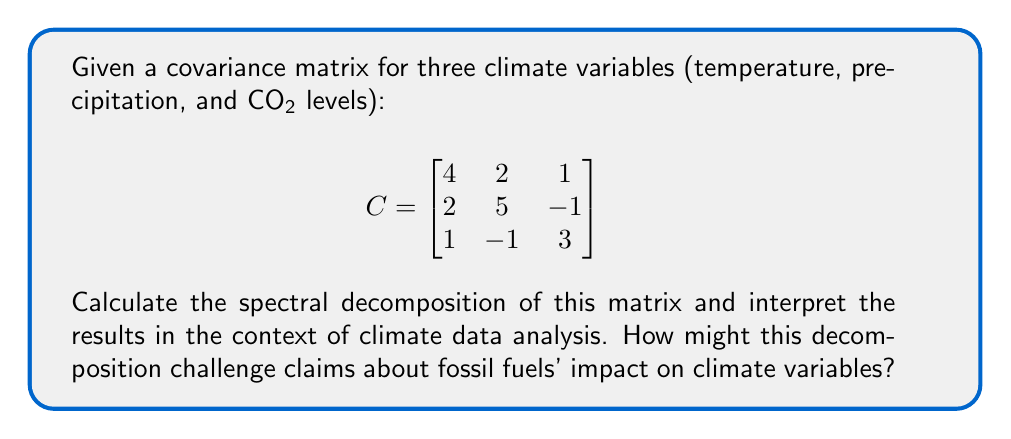Can you solve this math problem? 1) To find the spectral decomposition, we need to calculate the eigenvalues and eigenvectors of the covariance matrix C.

2) Find the eigenvalues by solving the characteristic equation:
   $$det(C - \lambda I) = 0$$
   $$(4-\lambda)(5-\lambda)(3-\lambda) - (4-\lambda)(-1)^2 - 1(5-\lambda) - 4(2)^2 + 2(2)(1) + 1(-1)(2) = 0$$
   $$-\lambda^3 + 12\lambda^2 - 41\lambda + 38 = 0$$

3) Solving this equation gives us the eigenvalues:
   $$\lambda_1 \approx 7.27, \lambda_2 \approx 3.54, \lambda_3 \approx 1.19$$

4) For each eigenvalue, find the corresponding eigenvector by solving:
   $$(C - \lambda_i I)v_i = 0$$

5) After normalization, the eigenvectors are approximately:
   $$v_1 \approx [0.52, 0.78, 0.35]^T$$
   $$v_2 \approx [-0.70, 0.09, 0.71]^T$$
   $$v_3 \approx [0.49, -0.62, 0.61]^T$$

6) The spectral decomposition is:
   $$C = V\Lambda V^T$$
   where $V$ is the matrix of eigenvectors and $\Lambda$ is the diagonal matrix of eigenvalues.

7) Interpretation: The first principal component (corresponding to $\lambda_1$) explains about 60.6% of the total variance, showing a strong positive correlation between all variables. The second component (29.5% of variance) contrasts CO2 levels with temperature. The third component (9.9% of variance) shows a complex relationship between all three variables.

8) This decomposition challenges simplistic claims about fossil fuels' impact by revealing complex interrelationships between climate variables. It suggests that while there is a dominant trend (PC1) where all variables increase together, there are also significant secondary patterns that complicate the picture.
Answer: $C = V\Lambda V^T$, where $V \approx [0.52, -0.70, 0.49; 0.78, 0.09, -0.62; 0.35, 0.71, 0.61]$ and $\Lambda \approx diag(7.27, 3.54, 1.19)$. This reveals complex, non-linear relationships between climate variables. 